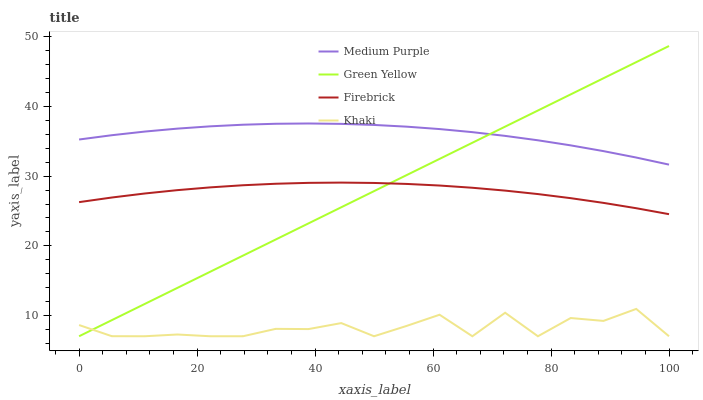Does Firebrick have the minimum area under the curve?
Answer yes or no. No. Does Firebrick have the maximum area under the curve?
Answer yes or no. No. Is Firebrick the smoothest?
Answer yes or no. No. Is Firebrick the roughest?
Answer yes or no. No. Does Firebrick have the lowest value?
Answer yes or no. No. Does Firebrick have the highest value?
Answer yes or no. No. Is Khaki less than Firebrick?
Answer yes or no. Yes. Is Medium Purple greater than Firebrick?
Answer yes or no. Yes. Does Khaki intersect Firebrick?
Answer yes or no. No. 